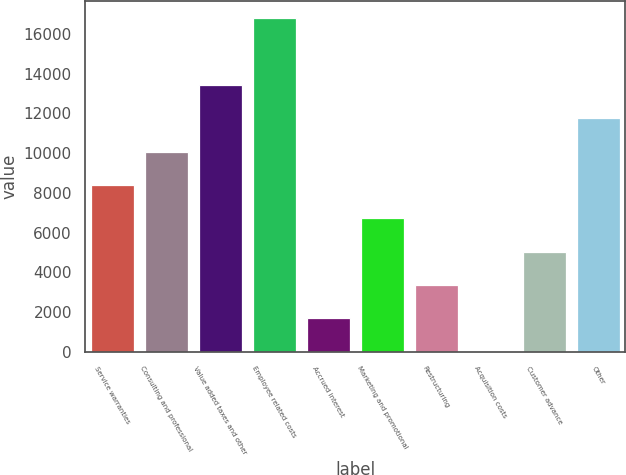<chart> <loc_0><loc_0><loc_500><loc_500><bar_chart><fcel>Service warranties<fcel>Consulting and professional<fcel>Value added taxes and other<fcel>Employee related costs<fcel>Accrued interest<fcel>Marketing and promotional<fcel>Restructuring<fcel>Acquisition costs<fcel>Customer advance<fcel>Other<nl><fcel>8398.83<fcel>10077.7<fcel>13435.3<fcel>16793<fcel>1683.51<fcel>6720<fcel>3362.34<fcel>4.68<fcel>5041.17<fcel>11756.5<nl></chart> 